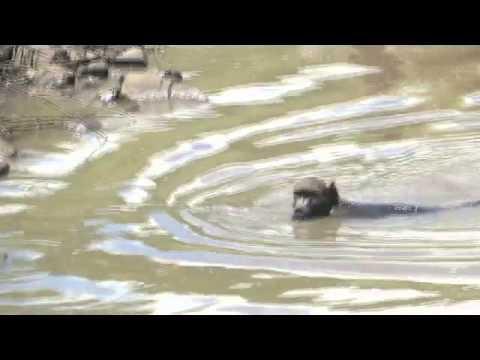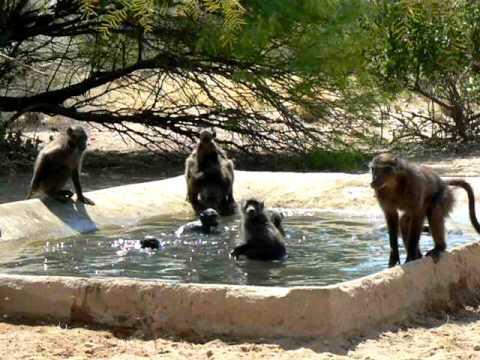The first image is the image on the left, the second image is the image on the right. Evaluate the accuracy of this statement regarding the images: "An animal in the image on the right is sitting on a concrete railing.". Is it true? Answer yes or no. Yes. The first image is the image on the left, the second image is the image on the right. Considering the images on both sides, is "An image includes a baboon sitting on a manmade ledge of a pool." valid? Answer yes or no. Yes. 